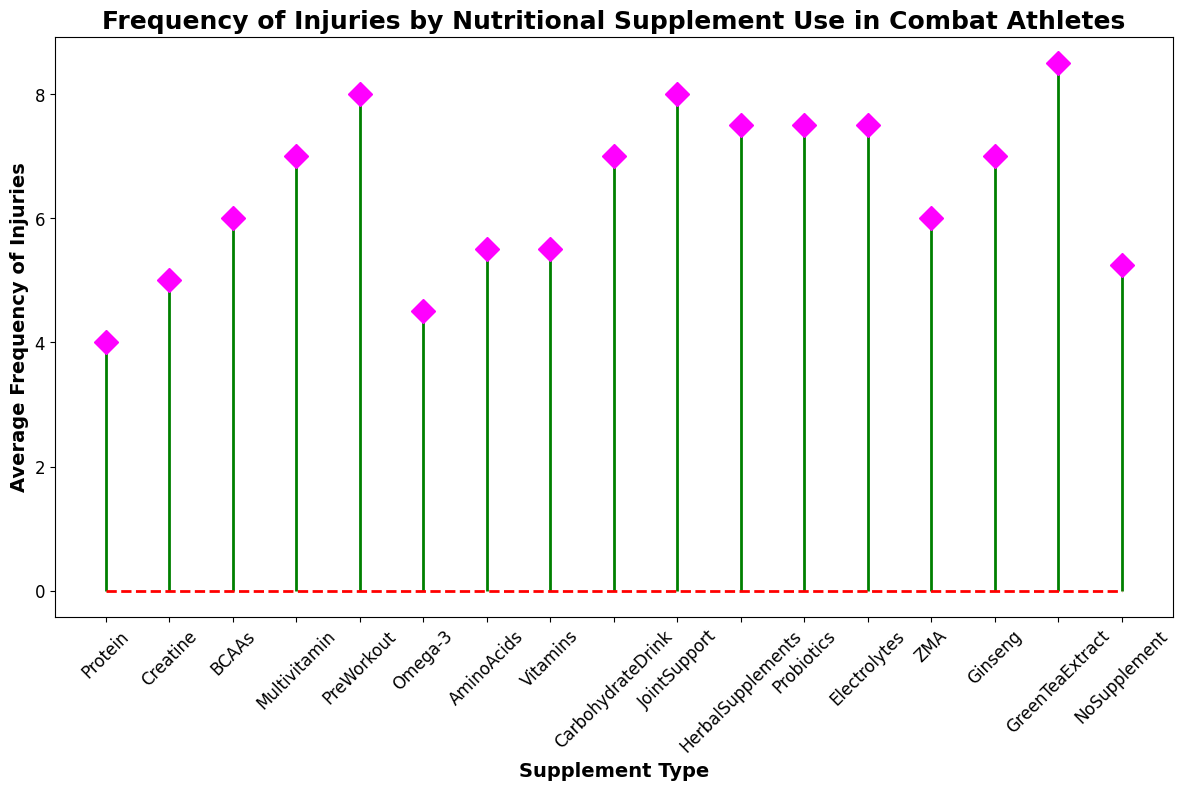what is the average frequency of injuries for athletes who take Protein supplements? We observe that there are two data points for Protein supplement usage with injury frequencies of 5 and 3. The average is calculated by summing these values and dividing by 2: (5 + 3) / 2 = 4
Answer: 4 Which supplement type is associated with the highest average frequency of injuries? By looking at the heights of the markers, GreenTeaExtract shows the highest average frequency at 8.5 injuries.
Answer: GreenTeaExtract How does the average frequency of injuries for athletes who take BCAAs compare to those who take Omega-3? For BCAAs, the average frequency is (7 + 5)/2 = 6. For Omega-3, it’s (5 + 4)/2 = 4.5. Hence, BCAAs have a higher average frequency than Omega-3.
Answer: BCAAs have a higher average Which supplements fall below an average injury frequency of 6? By checking the height of the markers, Protein (4), Omega-3 (4.5), AminoAcids (5.5), Vitamins (5.5), and NoSupplement (5.25) fall below an average frequency of 6.
Answer: Protein, Omega-3, AminoAcids, Vitamins, NoSupplement What is the combined average frequency of injuries for Creatine and PreWorkout users? The average for Creatine is (6 + 4)/2 = 5, and for PreWorkout, it’s (9 + 7)/2 = 8. Combined average frequency is (5 + 8)/2 = 6.5
Answer: 6.5 What is the difference between the highest and lowest average frequencies of injuries? The highest average frequency is from GreenTeaExtract at 8.5, and the lowest is Protein at 4. Therefore, the difference is 8.5 - 4 = 4.5
Answer: 4.5 Which supplement type shows a median average frequency of injuries? Arrange the averages: 4, 4.5, 5.25, 5.5, 5.5, 5.75, 6, 6, 6.5, 6.5, 6.5, 7, 7.5, 7.5, 7.5, 8, 8, 8.5, 8.5, and the median value is the 10th entry (average of middle two), which is 6.5. Hence, Creatine, PreWorkout, JointSupport, and CarbohydrateDrink all show a median at 6.5
Answer: Creatine, PreWorkout, JointSupport, CarbohydrateDrink What is the visual difference in marker shapes for GreenTeaExtract and Omega-3 supplements? The marker for GreenTeaExtract has a tall and magenta diamond shape, while the marker for Omega-3 has a relatively shorter height with a magenta diamond shape too.
Answer: Tall and magenta diamond for GreenTeaExtract, shorter magenta diamond for Omega-3 